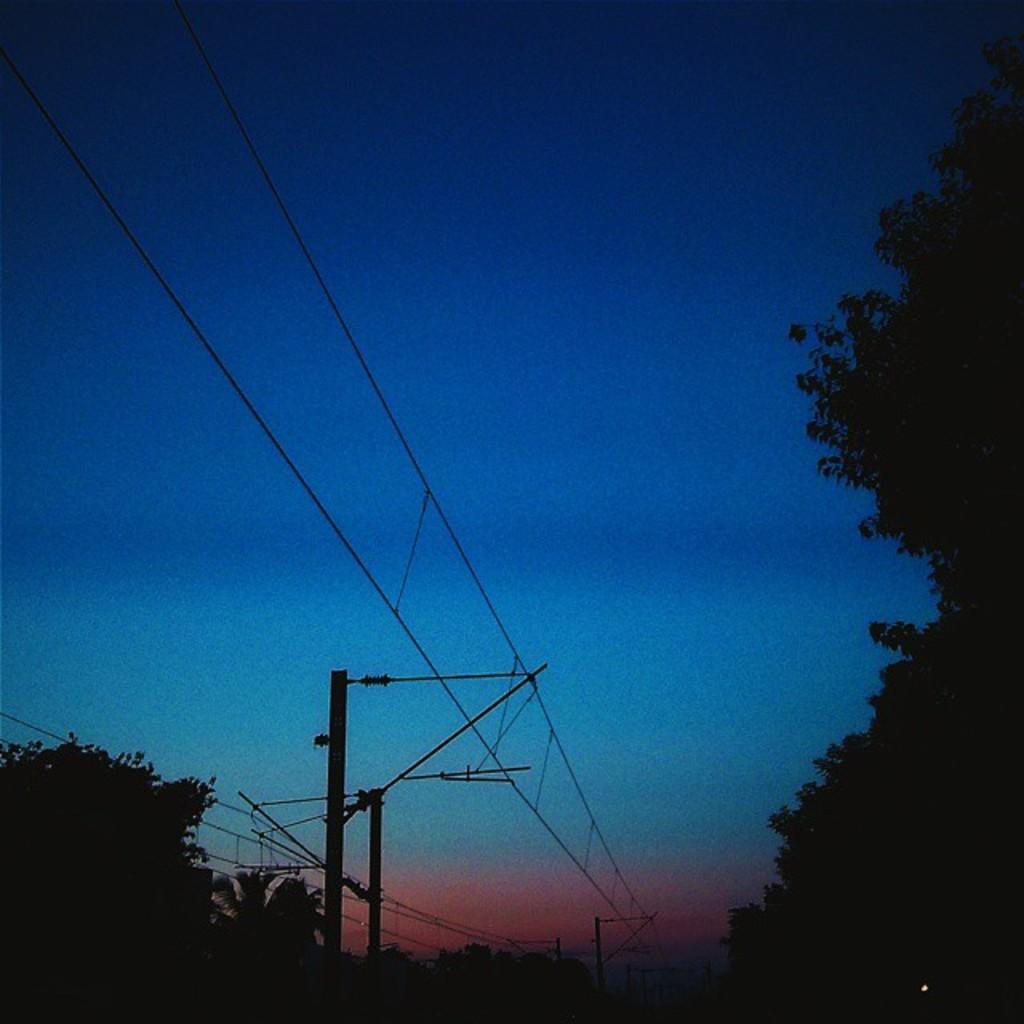Could you give a brief overview of what you see in this image? In the center of the image there are poles and wires. In the background there are trees and sky. 